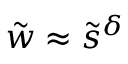Convert formula to latex. <formula><loc_0><loc_0><loc_500><loc_500>\tilde { w } \approx \tilde { s } ^ { \delta }</formula> 